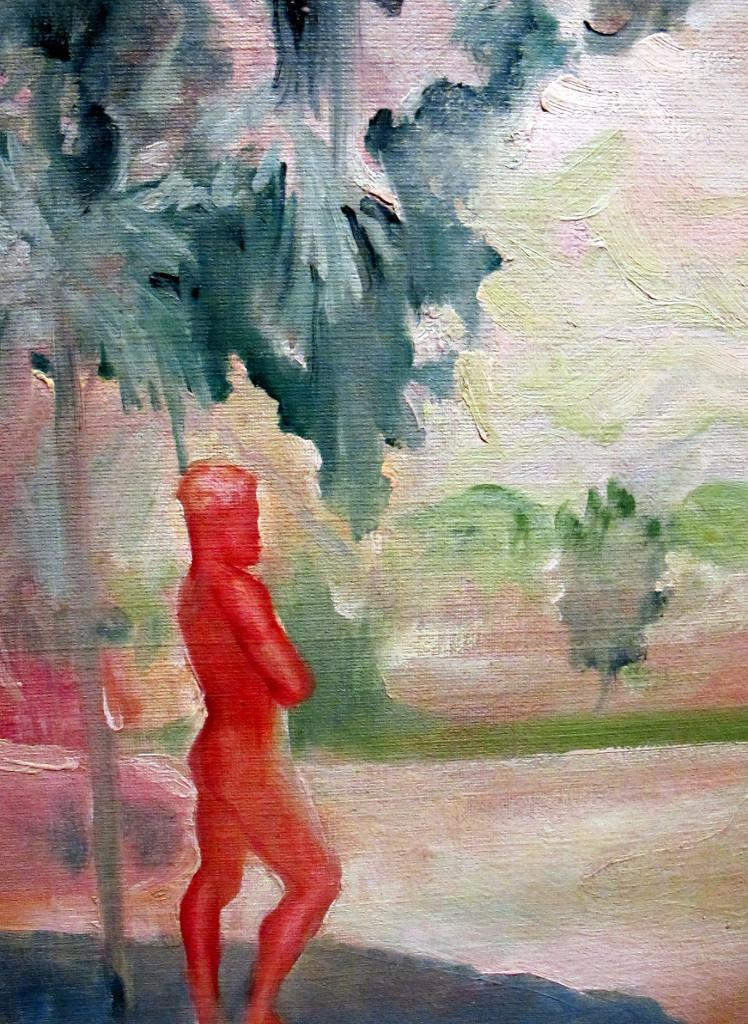What is the main subject of the image? There is a painting in the image. What other objects or elements can be seen in the image? There is a tree and a person standing in the image. What type of cork can be seen in the image? There is no cork present in the image. Is there a lamp visible in the image? No, there is no lamp visible in the image. 